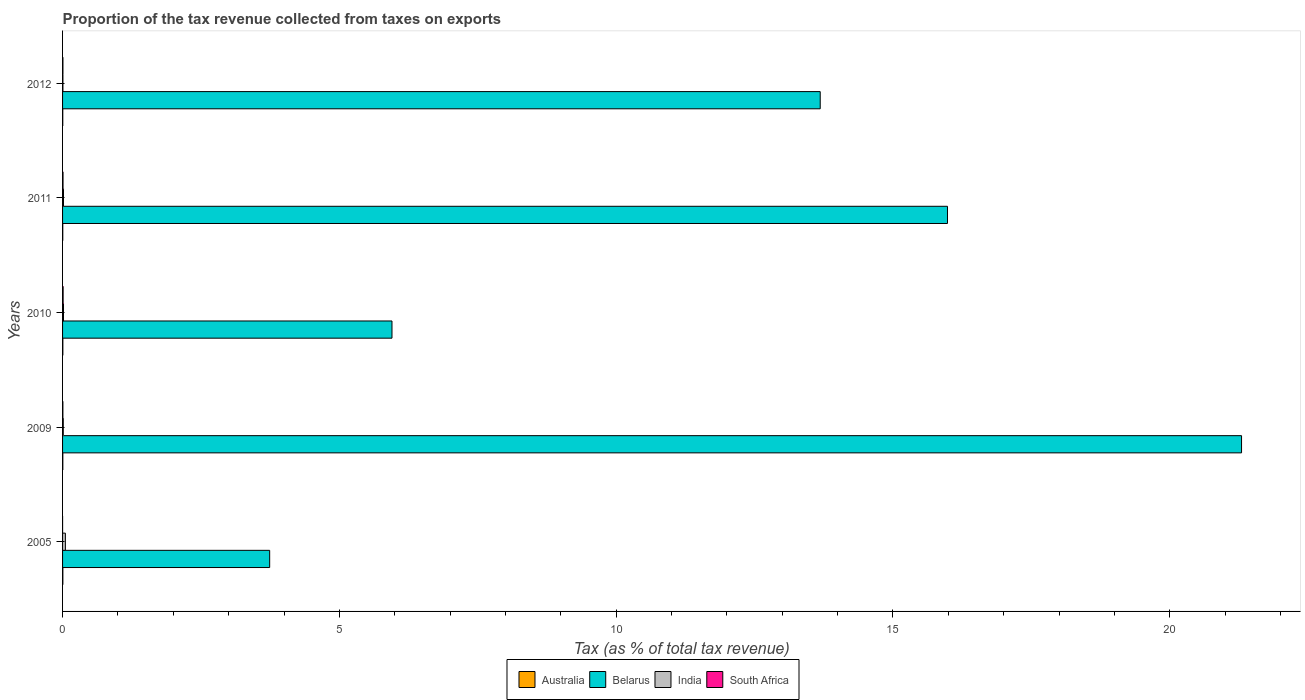In how many cases, is the number of bars for a given year not equal to the number of legend labels?
Give a very brief answer. 0. What is the proportion of the tax revenue collected in South Africa in 2011?
Your response must be concise. 0.01. Across all years, what is the maximum proportion of the tax revenue collected in India?
Offer a very short reply. 0.05. Across all years, what is the minimum proportion of the tax revenue collected in Australia?
Ensure brevity in your answer.  0. In which year was the proportion of the tax revenue collected in Belarus maximum?
Give a very brief answer. 2009. In which year was the proportion of the tax revenue collected in South Africa minimum?
Offer a terse response. 2005. What is the total proportion of the tax revenue collected in South Africa in the graph?
Provide a short and direct response. 0.03. What is the difference between the proportion of the tax revenue collected in South Africa in 2009 and that in 2012?
Your response must be concise. -0. What is the difference between the proportion of the tax revenue collected in India in 2005 and the proportion of the tax revenue collected in South Africa in 2009?
Keep it short and to the point. 0.05. What is the average proportion of the tax revenue collected in Australia per year?
Your response must be concise. 0. In the year 2012, what is the difference between the proportion of the tax revenue collected in Belarus and proportion of the tax revenue collected in Australia?
Offer a very short reply. 13.68. Is the proportion of the tax revenue collected in India in 2010 less than that in 2011?
Your answer should be very brief. No. Is the difference between the proportion of the tax revenue collected in Belarus in 2011 and 2012 greater than the difference between the proportion of the tax revenue collected in Australia in 2011 and 2012?
Offer a terse response. Yes. What is the difference between the highest and the second highest proportion of the tax revenue collected in South Africa?
Offer a very short reply. 0. What is the difference between the highest and the lowest proportion of the tax revenue collected in South Africa?
Offer a very short reply. 0.01. In how many years, is the proportion of the tax revenue collected in India greater than the average proportion of the tax revenue collected in India taken over all years?
Offer a terse response. 1. Is the sum of the proportion of the tax revenue collected in Belarus in 2009 and 2012 greater than the maximum proportion of the tax revenue collected in India across all years?
Offer a terse response. Yes. Is it the case that in every year, the sum of the proportion of the tax revenue collected in Belarus and proportion of the tax revenue collected in India is greater than the sum of proportion of the tax revenue collected in Australia and proportion of the tax revenue collected in South Africa?
Your answer should be very brief. Yes. What does the 4th bar from the bottom in 2010 represents?
Provide a succinct answer. South Africa. How many bars are there?
Your answer should be very brief. 20. Are all the bars in the graph horizontal?
Offer a terse response. Yes. What is the difference between two consecutive major ticks on the X-axis?
Make the answer very short. 5. Does the graph contain grids?
Ensure brevity in your answer.  No. How are the legend labels stacked?
Give a very brief answer. Horizontal. What is the title of the graph?
Ensure brevity in your answer.  Proportion of the tax revenue collected from taxes on exports. What is the label or title of the X-axis?
Give a very brief answer. Tax (as % of total tax revenue). What is the Tax (as % of total tax revenue) in Australia in 2005?
Offer a terse response. 0.01. What is the Tax (as % of total tax revenue) in Belarus in 2005?
Your answer should be very brief. 3.74. What is the Tax (as % of total tax revenue) in India in 2005?
Provide a succinct answer. 0.05. What is the Tax (as % of total tax revenue) in South Africa in 2005?
Your response must be concise. 0. What is the Tax (as % of total tax revenue) of Australia in 2009?
Keep it short and to the point. 0. What is the Tax (as % of total tax revenue) in Belarus in 2009?
Give a very brief answer. 21.3. What is the Tax (as % of total tax revenue) in India in 2009?
Your answer should be compact. 0.01. What is the Tax (as % of total tax revenue) of South Africa in 2009?
Your answer should be compact. 0.01. What is the Tax (as % of total tax revenue) of Australia in 2010?
Give a very brief answer. 0.01. What is the Tax (as % of total tax revenue) in Belarus in 2010?
Provide a succinct answer. 5.95. What is the Tax (as % of total tax revenue) in India in 2010?
Provide a succinct answer. 0.02. What is the Tax (as % of total tax revenue) of South Africa in 2010?
Your answer should be very brief. 0.01. What is the Tax (as % of total tax revenue) of Australia in 2011?
Provide a succinct answer. 0. What is the Tax (as % of total tax revenue) of Belarus in 2011?
Give a very brief answer. 15.98. What is the Tax (as % of total tax revenue) of India in 2011?
Provide a short and direct response. 0.02. What is the Tax (as % of total tax revenue) in South Africa in 2011?
Offer a very short reply. 0.01. What is the Tax (as % of total tax revenue) in Australia in 2012?
Provide a succinct answer. 0. What is the Tax (as % of total tax revenue) of Belarus in 2012?
Provide a short and direct response. 13.69. What is the Tax (as % of total tax revenue) of India in 2012?
Make the answer very short. 0.01. What is the Tax (as % of total tax revenue) of South Africa in 2012?
Ensure brevity in your answer.  0.01. Across all years, what is the maximum Tax (as % of total tax revenue) of Australia?
Ensure brevity in your answer.  0.01. Across all years, what is the maximum Tax (as % of total tax revenue) of Belarus?
Give a very brief answer. 21.3. Across all years, what is the maximum Tax (as % of total tax revenue) of India?
Give a very brief answer. 0.05. Across all years, what is the maximum Tax (as % of total tax revenue) of South Africa?
Provide a succinct answer. 0.01. Across all years, what is the minimum Tax (as % of total tax revenue) in Australia?
Keep it short and to the point. 0. Across all years, what is the minimum Tax (as % of total tax revenue) of Belarus?
Provide a succinct answer. 3.74. Across all years, what is the minimum Tax (as % of total tax revenue) in India?
Offer a terse response. 0.01. Across all years, what is the minimum Tax (as % of total tax revenue) of South Africa?
Give a very brief answer. 0. What is the total Tax (as % of total tax revenue) of Australia in the graph?
Make the answer very short. 0.02. What is the total Tax (as % of total tax revenue) of Belarus in the graph?
Give a very brief answer. 60.66. What is the total Tax (as % of total tax revenue) of India in the graph?
Make the answer very short. 0.1. What is the total Tax (as % of total tax revenue) of South Africa in the graph?
Keep it short and to the point. 0.03. What is the difference between the Tax (as % of total tax revenue) of Australia in 2005 and that in 2009?
Provide a short and direct response. 0. What is the difference between the Tax (as % of total tax revenue) in Belarus in 2005 and that in 2009?
Give a very brief answer. -17.56. What is the difference between the Tax (as % of total tax revenue) of India in 2005 and that in 2009?
Give a very brief answer. 0.04. What is the difference between the Tax (as % of total tax revenue) of South Africa in 2005 and that in 2009?
Provide a short and direct response. -0.01. What is the difference between the Tax (as % of total tax revenue) in Australia in 2005 and that in 2010?
Provide a succinct answer. -0. What is the difference between the Tax (as % of total tax revenue) of Belarus in 2005 and that in 2010?
Ensure brevity in your answer.  -2.21. What is the difference between the Tax (as % of total tax revenue) of India in 2005 and that in 2010?
Your answer should be very brief. 0.03. What is the difference between the Tax (as % of total tax revenue) in South Africa in 2005 and that in 2010?
Provide a succinct answer. -0.01. What is the difference between the Tax (as % of total tax revenue) in Australia in 2005 and that in 2011?
Provide a succinct answer. 0. What is the difference between the Tax (as % of total tax revenue) of Belarus in 2005 and that in 2011?
Your answer should be compact. -12.24. What is the difference between the Tax (as % of total tax revenue) of India in 2005 and that in 2011?
Ensure brevity in your answer.  0.03. What is the difference between the Tax (as % of total tax revenue) of South Africa in 2005 and that in 2011?
Ensure brevity in your answer.  -0.01. What is the difference between the Tax (as % of total tax revenue) in Australia in 2005 and that in 2012?
Offer a very short reply. 0. What is the difference between the Tax (as % of total tax revenue) of Belarus in 2005 and that in 2012?
Provide a succinct answer. -9.94. What is the difference between the Tax (as % of total tax revenue) in India in 2005 and that in 2012?
Your response must be concise. 0.04. What is the difference between the Tax (as % of total tax revenue) in South Africa in 2005 and that in 2012?
Offer a very short reply. -0.01. What is the difference between the Tax (as % of total tax revenue) in Australia in 2009 and that in 2010?
Provide a succinct answer. -0. What is the difference between the Tax (as % of total tax revenue) of Belarus in 2009 and that in 2010?
Your answer should be very brief. 15.35. What is the difference between the Tax (as % of total tax revenue) of India in 2009 and that in 2010?
Offer a terse response. -0. What is the difference between the Tax (as % of total tax revenue) of South Africa in 2009 and that in 2010?
Offer a very short reply. -0. What is the difference between the Tax (as % of total tax revenue) in Australia in 2009 and that in 2011?
Make the answer very short. 0. What is the difference between the Tax (as % of total tax revenue) of Belarus in 2009 and that in 2011?
Ensure brevity in your answer.  5.31. What is the difference between the Tax (as % of total tax revenue) in India in 2009 and that in 2011?
Your response must be concise. -0. What is the difference between the Tax (as % of total tax revenue) of South Africa in 2009 and that in 2011?
Offer a very short reply. -0. What is the difference between the Tax (as % of total tax revenue) of Australia in 2009 and that in 2012?
Provide a succinct answer. 0. What is the difference between the Tax (as % of total tax revenue) in Belarus in 2009 and that in 2012?
Provide a short and direct response. 7.61. What is the difference between the Tax (as % of total tax revenue) in India in 2009 and that in 2012?
Your answer should be compact. 0.01. What is the difference between the Tax (as % of total tax revenue) of South Africa in 2009 and that in 2012?
Offer a terse response. -0. What is the difference between the Tax (as % of total tax revenue) in Australia in 2010 and that in 2011?
Your answer should be very brief. 0. What is the difference between the Tax (as % of total tax revenue) of Belarus in 2010 and that in 2011?
Make the answer very short. -10.03. What is the difference between the Tax (as % of total tax revenue) of South Africa in 2010 and that in 2011?
Provide a succinct answer. 0. What is the difference between the Tax (as % of total tax revenue) in Australia in 2010 and that in 2012?
Offer a terse response. 0. What is the difference between the Tax (as % of total tax revenue) of Belarus in 2010 and that in 2012?
Provide a succinct answer. -7.74. What is the difference between the Tax (as % of total tax revenue) of India in 2010 and that in 2012?
Your response must be concise. 0.01. What is the difference between the Tax (as % of total tax revenue) in South Africa in 2010 and that in 2012?
Your answer should be very brief. 0. What is the difference between the Tax (as % of total tax revenue) of Australia in 2011 and that in 2012?
Provide a succinct answer. 0. What is the difference between the Tax (as % of total tax revenue) in Belarus in 2011 and that in 2012?
Keep it short and to the point. 2.3. What is the difference between the Tax (as % of total tax revenue) of India in 2011 and that in 2012?
Provide a short and direct response. 0.01. What is the difference between the Tax (as % of total tax revenue) of South Africa in 2011 and that in 2012?
Ensure brevity in your answer.  0. What is the difference between the Tax (as % of total tax revenue) of Australia in 2005 and the Tax (as % of total tax revenue) of Belarus in 2009?
Offer a very short reply. -21.29. What is the difference between the Tax (as % of total tax revenue) of Australia in 2005 and the Tax (as % of total tax revenue) of India in 2009?
Ensure brevity in your answer.  -0.01. What is the difference between the Tax (as % of total tax revenue) in Australia in 2005 and the Tax (as % of total tax revenue) in South Africa in 2009?
Give a very brief answer. -0. What is the difference between the Tax (as % of total tax revenue) of Belarus in 2005 and the Tax (as % of total tax revenue) of India in 2009?
Give a very brief answer. 3.73. What is the difference between the Tax (as % of total tax revenue) of Belarus in 2005 and the Tax (as % of total tax revenue) of South Africa in 2009?
Your response must be concise. 3.73. What is the difference between the Tax (as % of total tax revenue) of India in 2005 and the Tax (as % of total tax revenue) of South Africa in 2009?
Give a very brief answer. 0.05. What is the difference between the Tax (as % of total tax revenue) in Australia in 2005 and the Tax (as % of total tax revenue) in Belarus in 2010?
Your answer should be compact. -5.95. What is the difference between the Tax (as % of total tax revenue) in Australia in 2005 and the Tax (as % of total tax revenue) in India in 2010?
Your answer should be compact. -0.01. What is the difference between the Tax (as % of total tax revenue) in Australia in 2005 and the Tax (as % of total tax revenue) in South Africa in 2010?
Provide a short and direct response. -0.01. What is the difference between the Tax (as % of total tax revenue) of Belarus in 2005 and the Tax (as % of total tax revenue) of India in 2010?
Give a very brief answer. 3.72. What is the difference between the Tax (as % of total tax revenue) of Belarus in 2005 and the Tax (as % of total tax revenue) of South Africa in 2010?
Your answer should be very brief. 3.73. What is the difference between the Tax (as % of total tax revenue) in India in 2005 and the Tax (as % of total tax revenue) in South Africa in 2010?
Make the answer very short. 0.04. What is the difference between the Tax (as % of total tax revenue) in Australia in 2005 and the Tax (as % of total tax revenue) in Belarus in 2011?
Provide a short and direct response. -15.98. What is the difference between the Tax (as % of total tax revenue) in Australia in 2005 and the Tax (as % of total tax revenue) in India in 2011?
Your response must be concise. -0.01. What is the difference between the Tax (as % of total tax revenue) of Australia in 2005 and the Tax (as % of total tax revenue) of South Africa in 2011?
Your answer should be compact. -0. What is the difference between the Tax (as % of total tax revenue) of Belarus in 2005 and the Tax (as % of total tax revenue) of India in 2011?
Your answer should be very brief. 3.72. What is the difference between the Tax (as % of total tax revenue) in Belarus in 2005 and the Tax (as % of total tax revenue) in South Africa in 2011?
Provide a short and direct response. 3.73. What is the difference between the Tax (as % of total tax revenue) of India in 2005 and the Tax (as % of total tax revenue) of South Africa in 2011?
Your answer should be compact. 0.04. What is the difference between the Tax (as % of total tax revenue) of Australia in 2005 and the Tax (as % of total tax revenue) of Belarus in 2012?
Give a very brief answer. -13.68. What is the difference between the Tax (as % of total tax revenue) of Australia in 2005 and the Tax (as % of total tax revenue) of India in 2012?
Your answer should be compact. -0. What is the difference between the Tax (as % of total tax revenue) in Australia in 2005 and the Tax (as % of total tax revenue) in South Africa in 2012?
Offer a very short reply. -0. What is the difference between the Tax (as % of total tax revenue) of Belarus in 2005 and the Tax (as % of total tax revenue) of India in 2012?
Ensure brevity in your answer.  3.73. What is the difference between the Tax (as % of total tax revenue) of Belarus in 2005 and the Tax (as % of total tax revenue) of South Africa in 2012?
Ensure brevity in your answer.  3.73. What is the difference between the Tax (as % of total tax revenue) in India in 2005 and the Tax (as % of total tax revenue) in South Africa in 2012?
Your response must be concise. 0.04. What is the difference between the Tax (as % of total tax revenue) of Australia in 2009 and the Tax (as % of total tax revenue) of Belarus in 2010?
Make the answer very short. -5.95. What is the difference between the Tax (as % of total tax revenue) in Australia in 2009 and the Tax (as % of total tax revenue) in India in 2010?
Provide a short and direct response. -0.01. What is the difference between the Tax (as % of total tax revenue) in Australia in 2009 and the Tax (as % of total tax revenue) in South Africa in 2010?
Your answer should be very brief. -0.01. What is the difference between the Tax (as % of total tax revenue) of Belarus in 2009 and the Tax (as % of total tax revenue) of India in 2010?
Your response must be concise. 21.28. What is the difference between the Tax (as % of total tax revenue) of Belarus in 2009 and the Tax (as % of total tax revenue) of South Africa in 2010?
Your answer should be very brief. 21.29. What is the difference between the Tax (as % of total tax revenue) in India in 2009 and the Tax (as % of total tax revenue) in South Africa in 2010?
Offer a very short reply. 0. What is the difference between the Tax (as % of total tax revenue) of Australia in 2009 and the Tax (as % of total tax revenue) of Belarus in 2011?
Your answer should be compact. -15.98. What is the difference between the Tax (as % of total tax revenue) of Australia in 2009 and the Tax (as % of total tax revenue) of India in 2011?
Keep it short and to the point. -0.01. What is the difference between the Tax (as % of total tax revenue) in Australia in 2009 and the Tax (as % of total tax revenue) in South Africa in 2011?
Your answer should be very brief. -0. What is the difference between the Tax (as % of total tax revenue) of Belarus in 2009 and the Tax (as % of total tax revenue) of India in 2011?
Give a very brief answer. 21.28. What is the difference between the Tax (as % of total tax revenue) in Belarus in 2009 and the Tax (as % of total tax revenue) in South Africa in 2011?
Ensure brevity in your answer.  21.29. What is the difference between the Tax (as % of total tax revenue) of India in 2009 and the Tax (as % of total tax revenue) of South Africa in 2011?
Offer a very short reply. 0. What is the difference between the Tax (as % of total tax revenue) in Australia in 2009 and the Tax (as % of total tax revenue) in Belarus in 2012?
Provide a succinct answer. -13.68. What is the difference between the Tax (as % of total tax revenue) in Australia in 2009 and the Tax (as % of total tax revenue) in India in 2012?
Offer a terse response. -0. What is the difference between the Tax (as % of total tax revenue) in Australia in 2009 and the Tax (as % of total tax revenue) in South Africa in 2012?
Your response must be concise. -0. What is the difference between the Tax (as % of total tax revenue) of Belarus in 2009 and the Tax (as % of total tax revenue) of India in 2012?
Provide a short and direct response. 21.29. What is the difference between the Tax (as % of total tax revenue) in Belarus in 2009 and the Tax (as % of total tax revenue) in South Africa in 2012?
Give a very brief answer. 21.29. What is the difference between the Tax (as % of total tax revenue) of India in 2009 and the Tax (as % of total tax revenue) of South Africa in 2012?
Your answer should be very brief. 0.01. What is the difference between the Tax (as % of total tax revenue) of Australia in 2010 and the Tax (as % of total tax revenue) of Belarus in 2011?
Provide a succinct answer. -15.98. What is the difference between the Tax (as % of total tax revenue) of Australia in 2010 and the Tax (as % of total tax revenue) of India in 2011?
Make the answer very short. -0.01. What is the difference between the Tax (as % of total tax revenue) of Australia in 2010 and the Tax (as % of total tax revenue) of South Africa in 2011?
Give a very brief answer. -0. What is the difference between the Tax (as % of total tax revenue) in Belarus in 2010 and the Tax (as % of total tax revenue) in India in 2011?
Ensure brevity in your answer.  5.93. What is the difference between the Tax (as % of total tax revenue) in Belarus in 2010 and the Tax (as % of total tax revenue) in South Africa in 2011?
Make the answer very short. 5.94. What is the difference between the Tax (as % of total tax revenue) in India in 2010 and the Tax (as % of total tax revenue) in South Africa in 2011?
Make the answer very short. 0.01. What is the difference between the Tax (as % of total tax revenue) in Australia in 2010 and the Tax (as % of total tax revenue) in Belarus in 2012?
Your response must be concise. -13.68. What is the difference between the Tax (as % of total tax revenue) of Australia in 2010 and the Tax (as % of total tax revenue) of India in 2012?
Ensure brevity in your answer.  -0. What is the difference between the Tax (as % of total tax revenue) in Australia in 2010 and the Tax (as % of total tax revenue) in South Africa in 2012?
Your response must be concise. -0. What is the difference between the Tax (as % of total tax revenue) of Belarus in 2010 and the Tax (as % of total tax revenue) of India in 2012?
Give a very brief answer. 5.94. What is the difference between the Tax (as % of total tax revenue) in Belarus in 2010 and the Tax (as % of total tax revenue) in South Africa in 2012?
Your answer should be compact. 5.94. What is the difference between the Tax (as % of total tax revenue) in India in 2010 and the Tax (as % of total tax revenue) in South Africa in 2012?
Make the answer very short. 0.01. What is the difference between the Tax (as % of total tax revenue) of Australia in 2011 and the Tax (as % of total tax revenue) of Belarus in 2012?
Offer a terse response. -13.68. What is the difference between the Tax (as % of total tax revenue) in Australia in 2011 and the Tax (as % of total tax revenue) in India in 2012?
Keep it short and to the point. -0. What is the difference between the Tax (as % of total tax revenue) in Australia in 2011 and the Tax (as % of total tax revenue) in South Africa in 2012?
Offer a very short reply. -0. What is the difference between the Tax (as % of total tax revenue) of Belarus in 2011 and the Tax (as % of total tax revenue) of India in 2012?
Offer a very short reply. 15.98. What is the difference between the Tax (as % of total tax revenue) in Belarus in 2011 and the Tax (as % of total tax revenue) in South Africa in 2012?
Provide a succinct answer. 15.98. What is the difference between the Tax (as % of total tax revenue) of India in 2011 and the Tax (as % of total tax revenue) of South Africa in 2012?
Your answer should be very brief. 0.01. What is the average Tax (as % of total tax revenue) in Australia per year?
Offer a terse response. 0. What is the average Tax (as % of total tax revenue) in Belarus per year?
Your response must be concise. 12.13. What is the average Tax (as % of total tax revenue) of India per year?
Your answer should be compact. 0.02. What is the average Tax (as % of total tax revenue) of South Africa per year?
Give a very brief answer. 0.01. In the year 2005, what is the difference between the Tax (as % of total tax revenue) in Australia and Tax (as % of total tax revenue) in Belarus?
Keep it short and to the point. -3.74. In the year 2005, what is the difference between the Tax (as % of total tax revenue) in Australia and Tax (as % of total tax revenue) in India?
Provide a succinct answer. -0.05. In the year 2005, what is the difference between the Tax (as % of total tax revenue) of Australia and Tax (as % of total tax revenue) of South Africa?
Keep it short and to the point. 0.01. In the year 2005, what is the difference between the Tax (as % of total tax revenue) of Belarus and Tax (as % of total tax revenue) of India?
Provide a short and direct response. 3.69. In the year 2005, what is the difference between the Tax (as % of total tax revenue) of Belarus and Tax (as % of total tax revenue) of South Africa?
Ensure brevity in your answer.  3.74. In the year 2005, what is the difference between the Tax (as % of total tax revenue) in India and Tax (as % of total tax revenue) in South Africa?
Provide a succinct answer. 0.05. In the year 2009, what is the difference between the Tax (as % of total tax revenue) of Australia and Tax (as % of total tax revenue) of Belarus?
Ensure brevity in your answer.  -21.29. In the year 2009, what is the difference between the Tax (as % of total tax revenue) in Australia and Tax (as % of total tax revenue) in India?
Your answer should be compact. -0.01. In the year 2009, what is the difference between the Tax (as % of total tax revenue) of Australia and Tax (as % of total tax revenue) of South Africa?
Provide a short and direct response. -0. In the year 2009, what is the difference between the Tax (as % of total tax revenue) of Belarus and Tax (as % of total tax revenue) of India?
Make the answer very short. 21.28. In the year 2009, what is the difference between the Tax (as % of total tax revenue) of Belarus and Tax (as % of total tax revenue) of South Africa?
Your answer should be compact. 21.29. In the year 2009, what is the difference between the Tax (as % of total tax revenue) of India and Tax (as % of total tax revenue) of South Africa?
Your answer should be compact. 0.01. In the year 2010, what is the difference between the Tax (as % of total tax revenue) in Australia and Tax (as % of total tax revenue) in Belarus?
Your answer should be compact. -5.95. In the year 2010, what is the difference between the Tax (as % of total tax revenue) of Australia and Tax (as % of total tax revenue) of India?
Make the answer very short. -0.01. In the year 2010, what is the difference between the Tax (as % of total tax revenue) in Australia and Tax (as % of total tax revenue) in South Africa?
Provide a short and direct response. -0.01. In the year 2010, what is the difference between the Tax (as % of total tax revenue) of Belarus and Tax (as % of total tax revenue) of India?
Offer a very short reply. 5.93. In the year 2010, what is the difference between the Tax (as % of total tax revenue) of Belarus and Tax (as % of total tax revenue) of South Africa?
Offer a very short reply. 5.94. In the year 2010, what is the difference between the Tax (as % of total tax revenue) of India and Tax (as % of total tax revenue) of South Africa?
Offer a terse response. 0.01. In the year 2011, what is the difference between the Tax (as % of total tax revenue) in Australia and Tax (as % of total tax revenue) in Belarus?
Offer a very short reply. -15.98. In the year 2011, what is the difference between the Tax (as % of total tax revenue) of Australia and Tax (as % of total tax revenue) of India?
Your answer should be compact. -0.01. In the year 2011, what is the difference between the Tax (as % of total tax revenue) of Australia and Tax (as % of total tax revenue) of South Africa?
Your answer should be very brief. -0. In the year 2011, what is the difference between the Tax (as % of total tax revenue) in Belarus and Tax (as % of total tax revenue) in India?
Give a very brief answer. 15.97. In the year 2011, what is the difference between the Tax (as % of total tax revenue) in Belarus and Tax (as % of total tax revenue) in South Africa?
Your answer should be compact. 15.98. In the year 2011, what is the difference between the Tax (as % of total tax revenue) of India and Tax (as % of total tax revenue) of South Africa?
Your answer should be compact. 0.01. In the year 2012, what is the difference between the Tax (as % of total tax revenue) in Australia and Tax (as % of total tax revenue) in Belarus?
Provide a short and direct response. -13.68. In the year 2012, what is the difference between the Tax (as % of total tax revenue) in Australia and Tax (as % of total tax revenue) in India?
Provide a short and direct response. -0. In the year 2012, what is the difference between the Tax (as % of total tax revenue) of Australia and Tax (as % of total tax revenue) of South Africa?
Your answer should be very brief. -0. In the year 2012, what is the difference between the Tax (as % of total tax revenue) in Belarus and Tax (as % of total tax revenue) in India?
Your answer should be very brief. 13.68. In the year 2012, what is the difference between the Tax (as % of total tax revenue) in Belarus and Tax (as % of total tax revenue) in South Africa?
Give a very brief answer. 13.68. In the year 2012, what is the difference between the Tax (as % of total tax revenue) in India and Tax (as % of total tax revenue) in South Africa?
Offer a very short reply. -0. What is the ratio of the Tax (as % of total tax revenue) of Australia in 2005 to that in 2009?
Your answer should be compact. 1.12. What is the ratio of the Tax (as % of total tax revenue) in Belarus in 2005 to that in 2009?
Provide a short and direct response. 0.18. What is the ratio of the Tax (as % of total tax revenue) of India in 2005 to that in 2009?
Ensure brevity in your answer.  3.94. What is the ratio of the Tax (as % of total tax revenue) of South Africa in 2005 to that in 2009?
Ensure brevity in your answer.  0.04. What is the ratio of the Tax (as % of total tax revenue) in Australia in 2005 to that in 2010?
Provide a succinct answer. 1. What is the ratio of the Tax (as % of total tax revenue) of Belarus in 2005 to that in 2010?
Your answer should be compact. 0.63. What is the ratio of the Tax (as % of total tax revenue) of India in 2005 to that in 2010?
Ensure brevity in your answer.  3.05. What is the ratio of the Tax (as % of total tax revenue) of South Africa in 2005 to that in 2010?
Offer a terse response. 0.02. What is the ratio of the Tax (as % of total tax revenue) in Australia in 2005 to that in 2011?
Provide a succinct answer. 1.37. What is the ratio of the Tax (as % of total tax revenue) in Belarus in 2005 to that in 2011?
Make the answer very short. 0.23. What is the ratio of the Tax (as % of total tax revenue) in India in 2005 to that in 2011?
Offer a very short reply. 3.05. What is the ratio of the Tax (as % of total tax revenue) in South Africa in 2005 to that in 2011?
Your response must be concise. 0.03. What is the ratio of the Tax (as % of total tax revenue) of Australia in 2005 to that in 2012?
Your answer should be very brief. 1.39. What is the ratio of the Tax (as % of total tax revenue) of Belarus in 2005 to that in 2012?
Your response must be concise. 0.27. What is the ratio of the Tax (as % of total tax revenue) in India in 2005 to that in 2012?
Offer a terse response. 7.86. What is the ratio of the Tax (as % of total tax revenue) of South Africa in 2005 to that in 2012?
Make the answer very short. 0.04. What is the ratio of the Tax (as % of total tax revenue) in Australia in 2009 to that in 2010?
Make the answer very short. 0.89. What is the ratio of the Tax (as % of total tax revenue) of Belarus in 2009 to that in 2010?
Offer a very short reply. 3.58. What is the ratio of the Tax (as % of total tax revenue) of India in 2009 to that in 2010?
Keep it short and to the point. 0.77. What is the ratio of the Tax (as % of total tax revenue) of South Africa in 2009 to that in 2010?
Offer a very short reply. 0.58. What is the ratio of the Tax (as % of total tax revenue) of Australia in 2009 to that in 2011?
Your response must be concise. 1.22. What is the ratio of the Tax (as % of total tax revenue) in Belarus in 2009 to that in 2011?
Offer a terse response. 1.33. What is the ratio of the Tax (as % of total tax revenue) of India in 2009 to that in 2011?
Provide a succinct answer. 0.77. What is the ratio of the Tax (as % of total tax revenue) in South Africa in 2009 to that in 2011?
Provide a succinct answer. 0.7. What is the ratio of the Tax (as % of total tax revenue) of Australia in 2009 to that in 2012?
Your answer should be very brief. 1.24. What is the ratio of the Tax (as % of total tax revenue) in Belarus in 2009 to that in 2012?
Offer a very short reply. 1.56. What is the ratio of the Tax (as % of total tax revenue) in India in 2009 to that in 2012?
Your response must be concise. 2. What is the ratio of the Tax (as % of total tax revenue) of South Africa in 2009 to that in 2012?
Your answer should be compact. 0.88. What is the ratio of the Tax (as % of total tax revenue) of Australia in 2010 to that in 2011?
Make the answer very short. 1.37. What is the ratio of the Tax (as % of total tax revenue) in Belarus in 2010 to that in 2011?
Provide a short and direct response. 0.37. What is the ratio of the Tax (as % of total tax revenue) of India in 2010 to that in 2011?
Provide a short and direct response. 1. What is the ratio of the Tax (as % of total tax revenue) in South Africa in 2010 to that in 2011?
Give a very brief answer. 1.21. What is the ratio of the Tax (as % of total tax revenue) in Australia in 2010 to that in 2012?
Keep it short and to the point. 1.39. What is the ratio of the Tax (as % of total tax revenue) in Belarus in 2010 to that in 2012?
Provide a short and direct response. 0.43. What is the ratio of the Tax (as % of total tax revenue) in India in 2010 to that in 2012?
Provide a short and direct response. 2.58. What is the ratio of the Tax (as % of total tax revenue) of South Africa in 2010 to that in 2012?
Ensure brevity in your answer.  1.54. What is the ratio of the Tax (as % of total tax revenue) in Australia in 2011 to that in 2012?
Give a very brief answer. 1.01. What is the ratio of the Tax (as % of total tax revenue) of Belarus in 2011 to that in 2012?
Give a very brief answer. 1.17. What is the ratio of the Tax (as % of total tax revenue) of India in 2011 to that in 2012?
Give a very brief answer. 2.58. What is the ratio of the Tax (as % of total tax revenue) in South Africa in 2011 to that in 2012?
Offer a very short reply. 1.27. What is the difference between the highest and the second highest Tax (as % of total tax revenue) in Belarus?
Offer a terse response. 5.31. What is the difference between the highest and the second highest Tax (as % of total tax revenue) of India?
Make the answer very short. 0.03. What is the difference between the highest and the second highest Tax (as % of total tax revenue) of South Africa?
Provide a succinct answer. 0. What is the difference between the highest and the lowest Tax (as % of total tax revenue) in Australia?
Offer a very short reply. 0. What is the difference between the highest and the lowest Tax (as % of total tax revenue) of Belarus?
Offer a very short reply. 17.56. What is the difference between the highest and the lowest Tax (as % of total tax revenue) of India?
Your response must be concise. 0.04. 